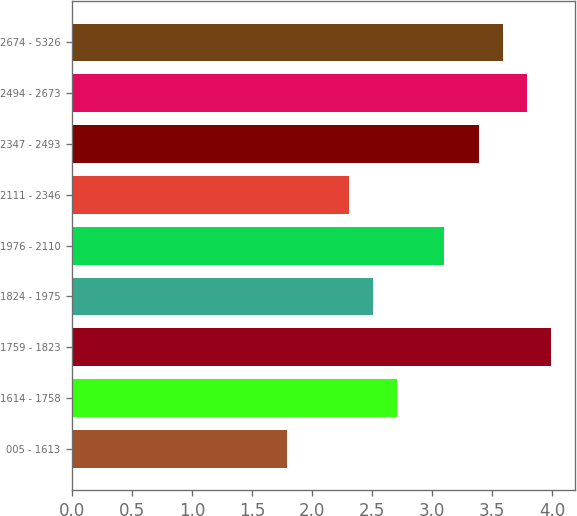Convert chart. <chart><loc_0><loc_0><loc_500><loc_500><bar_chart><fcel>005 - 1613<fcel>1614 - 1758<fcel>1759 - 1823<fcel>1824 - 1975<fcel>1976 - 2110<fcel>2111 - 2346<fcel>2347 - 2493<fcel>2494 - 2673<fcel>2674 - 5326<nl><fcel>1.79<fcel>2.71<fcel>3.99<fcel>2.51<fcel>3.1<fcel>2.31<fcel>3.39<fcel>3.79<fcel>3.59<nl></chart> 